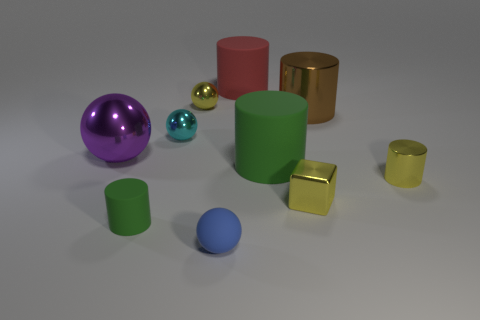Subtract all yellow balls. How many green cylinders are left? 2 Subtract all yellow metal cylinders. How many cylinders are left? 4 Subtract all green cylinders. How many cylinders are left? 3 Subtract all red cylinders. Subtract all cyan blocks. How many cylinders are left? 4 Add 1 small cyan metal spheres. How many small cyan metal spheres are left? 2 Add 9 green rubber blocks. How many green rubber blocks exist? 9 Subtract 0 green balls. How many objects are left? 10 Subtract all cubes. How many objects are left? 9 Subtract all purple spheres. Subtract all large purple metal cylinders. How many objects are left? 9 